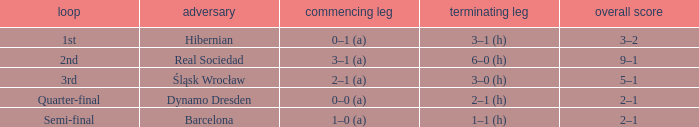What was the first leg against Hibernian? 0–1 (a). 